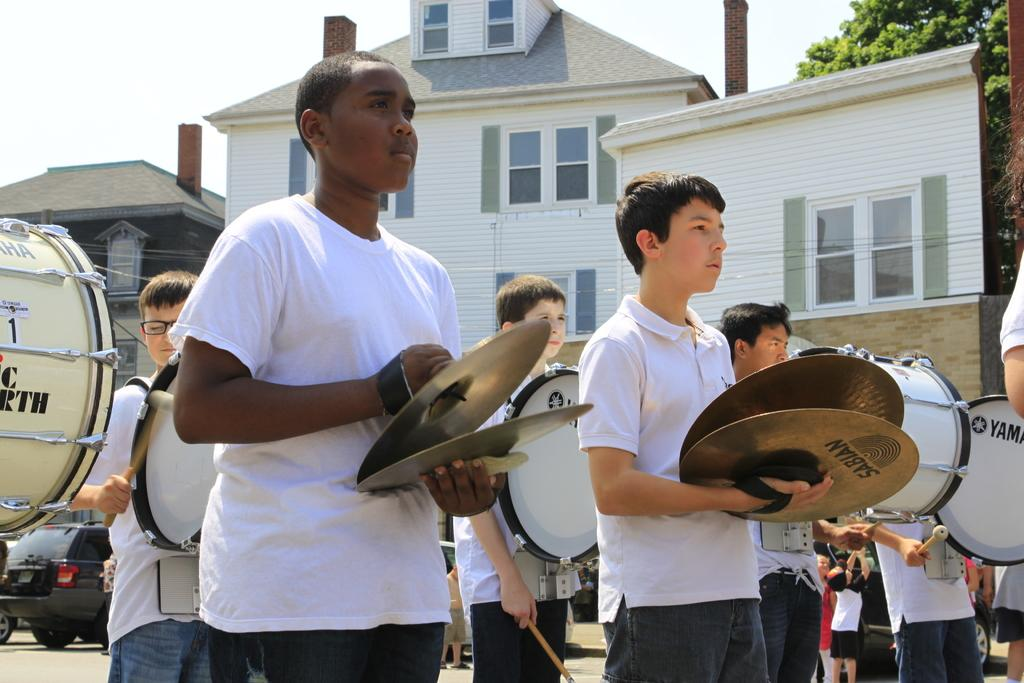Provide a one-sentence caption for the provided image. school band member useig instuments by sabian and yamaha. 